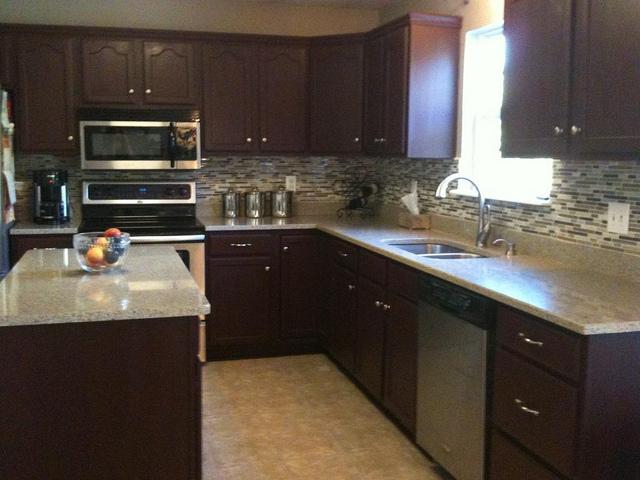How many appliances are there?
Give a very brief answer. 4. What room is that?
Answer briefly. Kitchen. What color are the kitchen cabinets?
Answer briefly. Brown. 